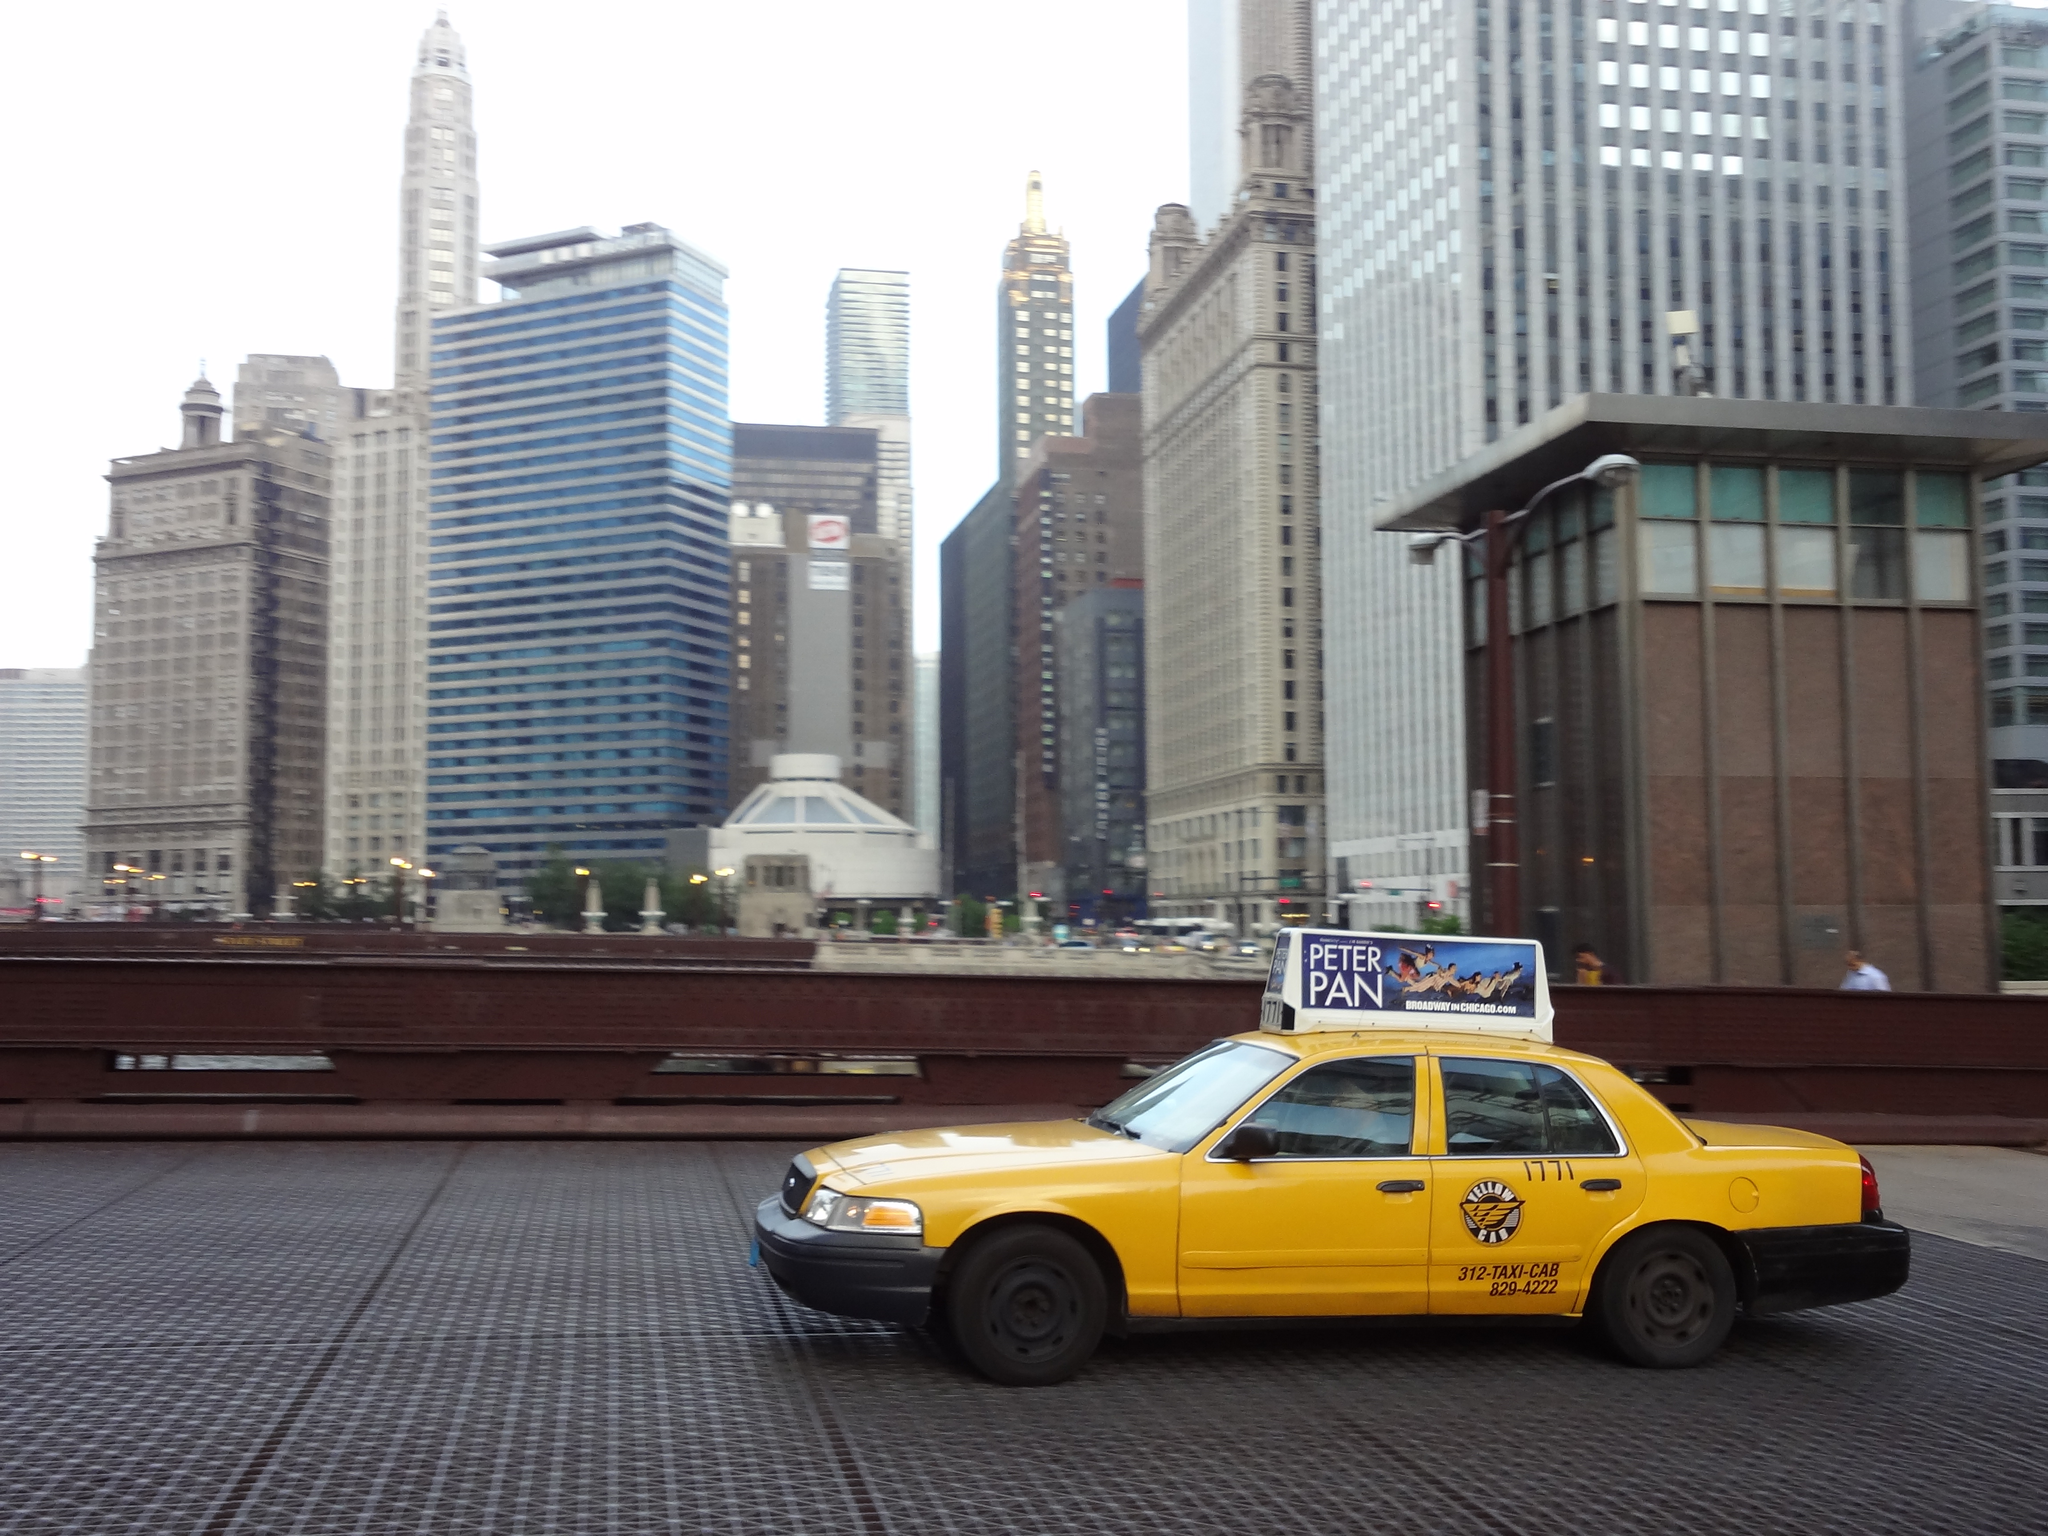<image>
Give a short and clear explanation of the subsequent image. A taxi cab has an advertisment for Peter Pan on the top of it. 